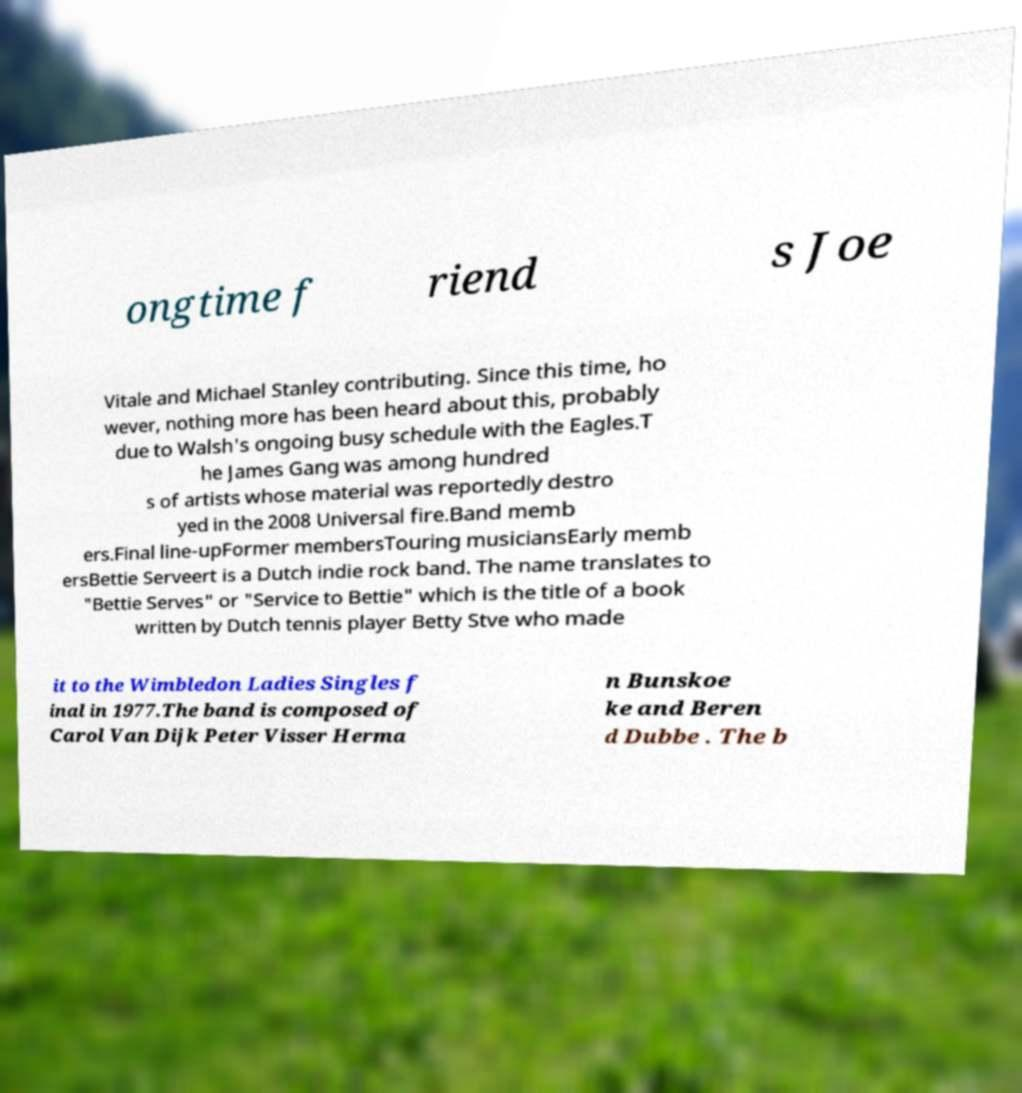Could you extract and type out the text from this image? ongtime f riend s Joe Vitale and Michael Stanley contributing. Since this time, ho wever, nothing more has been heard about this, probably due to Walsh's ongoing busy schedule with the Eagles.T he James Gang was among hundred s of artists whose material was reportedly destro yed in the 2008 Universal fire.Band memb ers.Final line-upFormer membersTouring musiciansEarly memb ersBettie Serveert is a Dutch indie rock band. The name translates to "Bettie Serves" or "Service to Bettie" which is the title of a book written by Dutch tennis player Betty Stve who made it to the Wimbledon Ladies Singles f inal in 1977.The band is composed of Carol Van Dijk Peter Visser Herma n Bunskoe ke and Beren d Dubbe . The b 